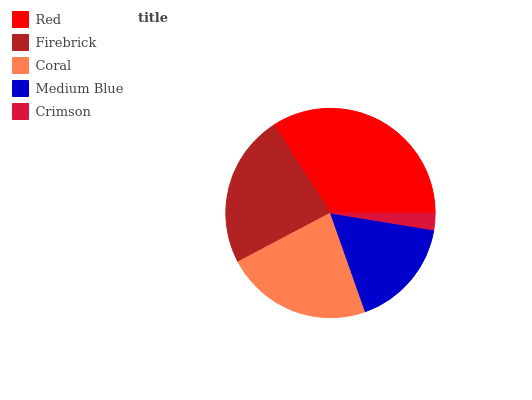Is Crimson the minimum?
Answer yes or no. Yes. Is Red the maximum?
Answer yes or no. Yes. Is Firebrick the minimum?
Answer yes or no. No. Is Firebrick the maximum?
Answer yes or no. No. Is Red greater than Firebrick?
Answer yes or no. Yes. Is Firebrick less than Red?
Answer yes or no. Yes. Is Firebrick greater than Red?
Answer yes or no. No. Is Red less than Firebrick?
Answer yes or no. No. Is Coral the high median?
Answer yes or no. Yes. Is Coral the low median?
Answer yes or no. Yes. Is Crimson the high median?
Answer yes or no. No. Is Crimson the low median?
Answer yes or no. No. 